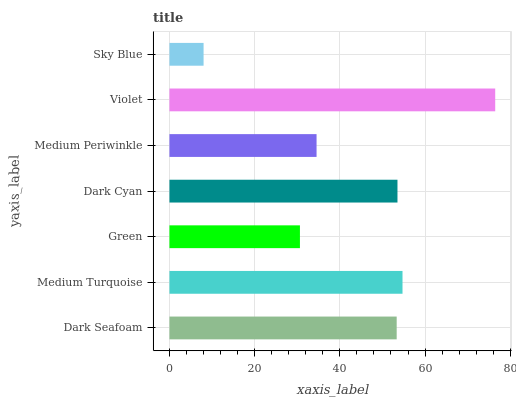Is Sky Blue the minimum?
Answer yes or no. Yes. Is Violet the maximum?
Answer yes or no. Yes. Is Medium Turquoise the minimum?
Answer yes or no. No. Is Medium Turquoise the maximum?
Answer yes or no. No. Is Medium Turquoise greater than Dark Seafoam?
Answer yes or no. Yes. Is Dark Seafoam less than Medium Turquoise?
Answer yes or no. Yes. Is Dark Seafoam greater than Medium Turquoise?
Answer yes or no. No. Is Medium Turquoise less than Dark Seafoam?
Answer yes or no. No. Is Dark Seafoam the high median?
Answer yes or no. Yes. Is Dark Seafoam the low median?
Answer yes or no. Yes. Is Violet the high median?
Answer yes or no. No. Is Sky Blue the low median?
Answer yes or no. No. 